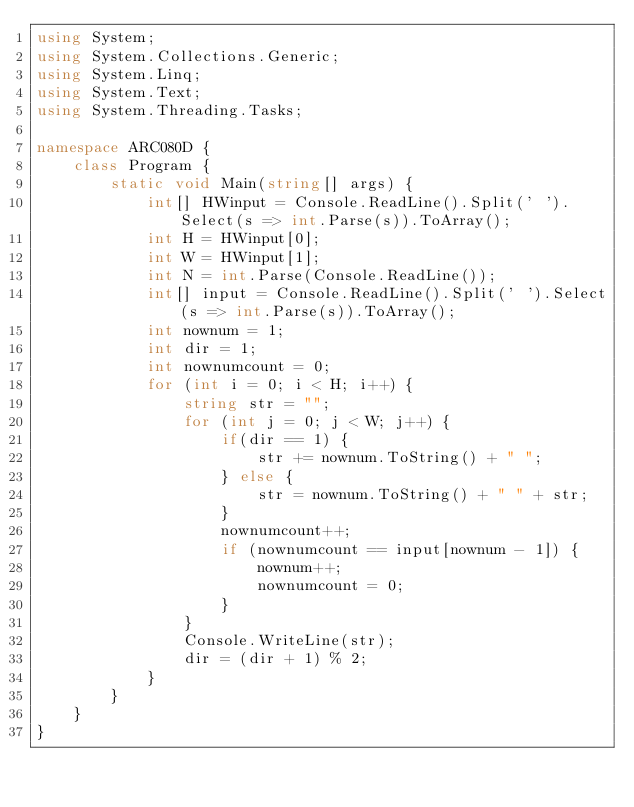<code> <loc_0><loc_0><loc_500><loc_500><_C#_>using System;
using System.Collections.Generic;
using System.Linq;
using System.Text;
using System.Threading.Tasks;

namespace ARC080D {
    class Program {
        static void Main(string[] args) {
            int[] HWinput = Console.ReadLine().Split(' ').Select(s => int.Parse(s)).ToArray();
            int H = HWinput[0];
            int W = HWinput[1];
            int N = int.Parse(Console.ReadLine());
            int[] input = Console.ReadLine().Split(' ').Select(s => int.Parse(s)).ToArray();
            int nownum = 1;
            int dir = 1;
            int nownumcount = 0;
            for (int i = 0; i < H; i++) {
                string str = "";
                for (int j = 0; j < W; j++) {
                    if(dir == 1) {
                        str += nownum.ToString() + " ";
                    } else {
                        str = nownum.ToString() + " " + str;
                    }
                    nownumcount++;
                    if (nownumcount == input[nownum - 1]) {
                        nownum++;
                        nownumcount = 0;
                    }
                }
                Console.WriteLine(str);
                dir = (dir + 1) % 2;
            }
        }
    }
}
</code> 